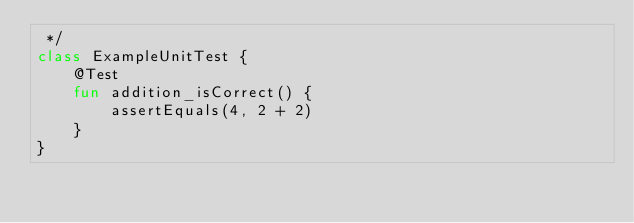<code> <loc_0><loc_0><loc_500><loc_500><_Kotlin_> */
class ExampleUnitTest {
    @Test
    fun addition_isCorrect() {
        assertEquals(4, 2 + 2)
    }
}</code> 